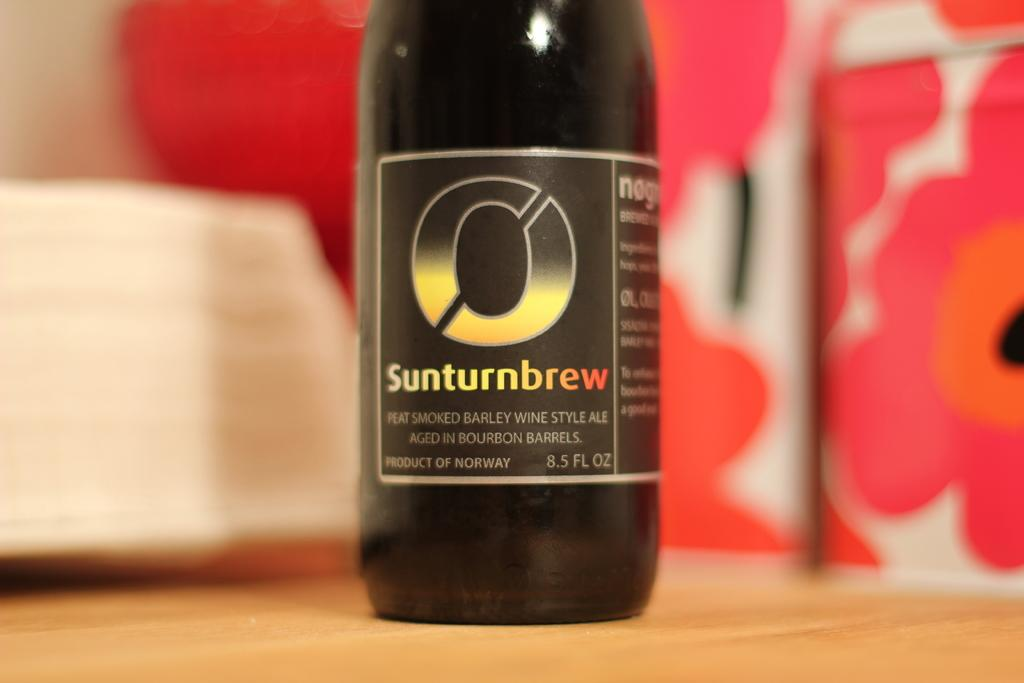<image>
Describe the image concisely. Black bottle with a label that says Sunturnbrew on it. 